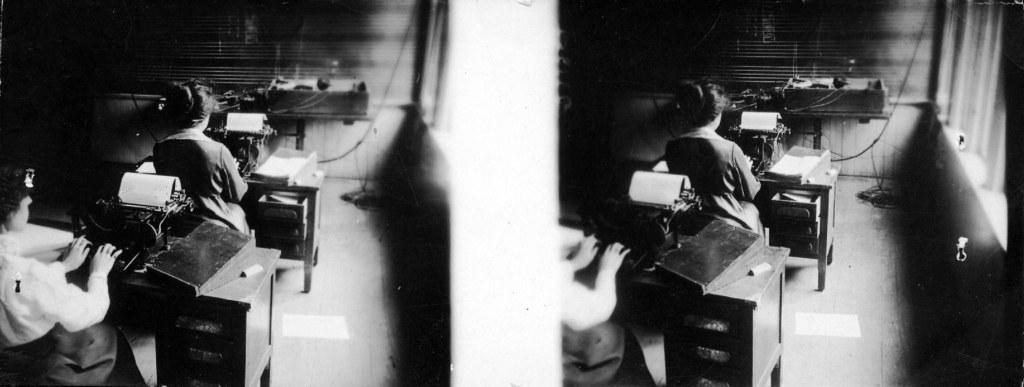What is depicted in the picture? There is a collage of two similar images in the picture. Who can be seen in the images? There are women seated in the image. What are the women doing in the image? The women are working on typing machines. Where are the typing machines located? The typing machines are on tables. What else can be seen on the tables? There are papers on the tables. What type of silver material is being used by the giants in the image? There are no giants or silver material present in the image. How many stitches can be seen on the women's clothing in the image? There is no mention of stitches or clothing details in the image; the focus is on the women working on typing machines. 